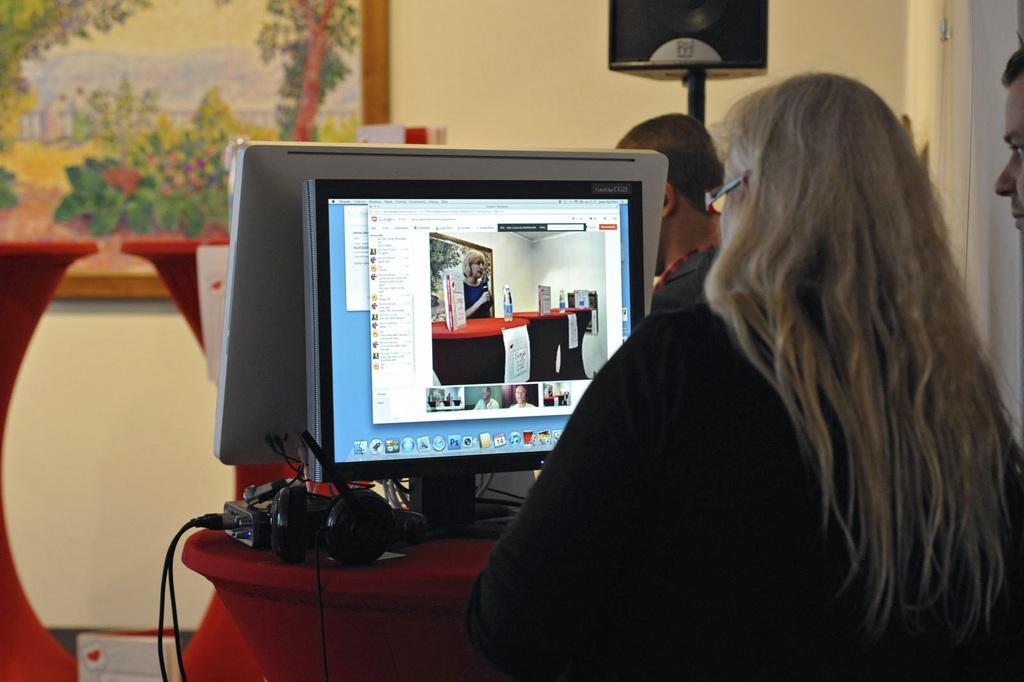Describe this image in one or two sentences. In this image I can see on the right side a woman is working in the monitor, on the left side there is a painting to this wall. In the middle there is a headset. 